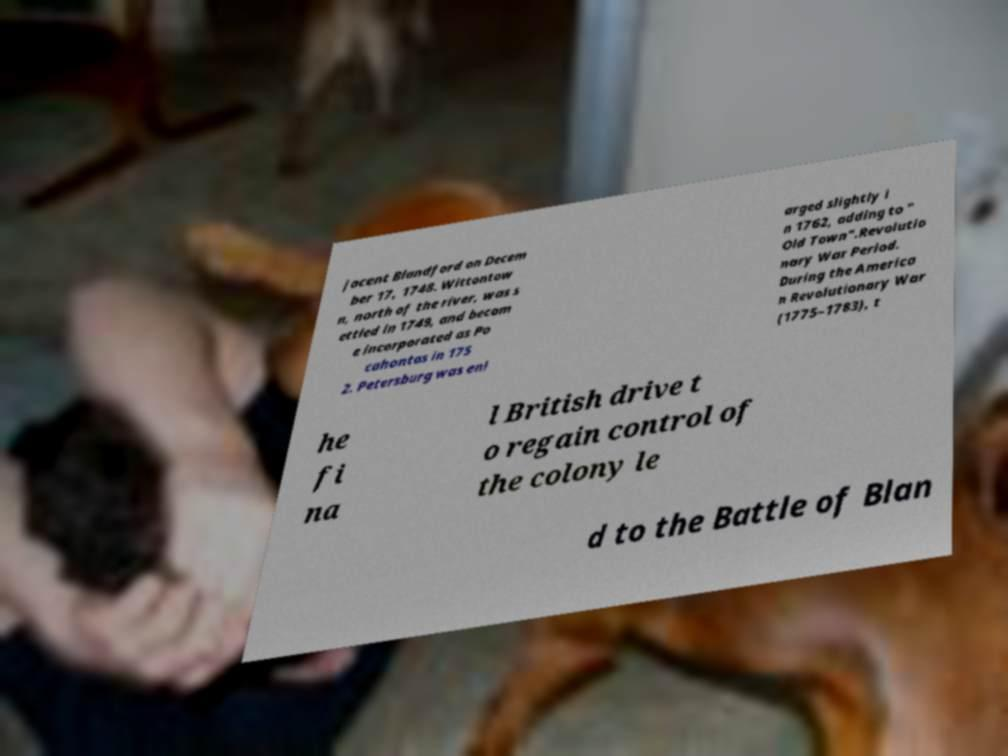Please read and relay the text visible in this image. What does it say? jacent Blandford on Decem ber 17, 1748. Wittontow n, north of the river, was s ettled in 1749, and becam e incorporated as Po cahontas in 175 2. Petersburg was enl arged slightly i n 1762, adding to " Old Town".Revolutio nary War Period. During the America n Revolutionary War (1775–1783), t he fi na l British drive t o regain control of the colony le d to the Battle of Blan 